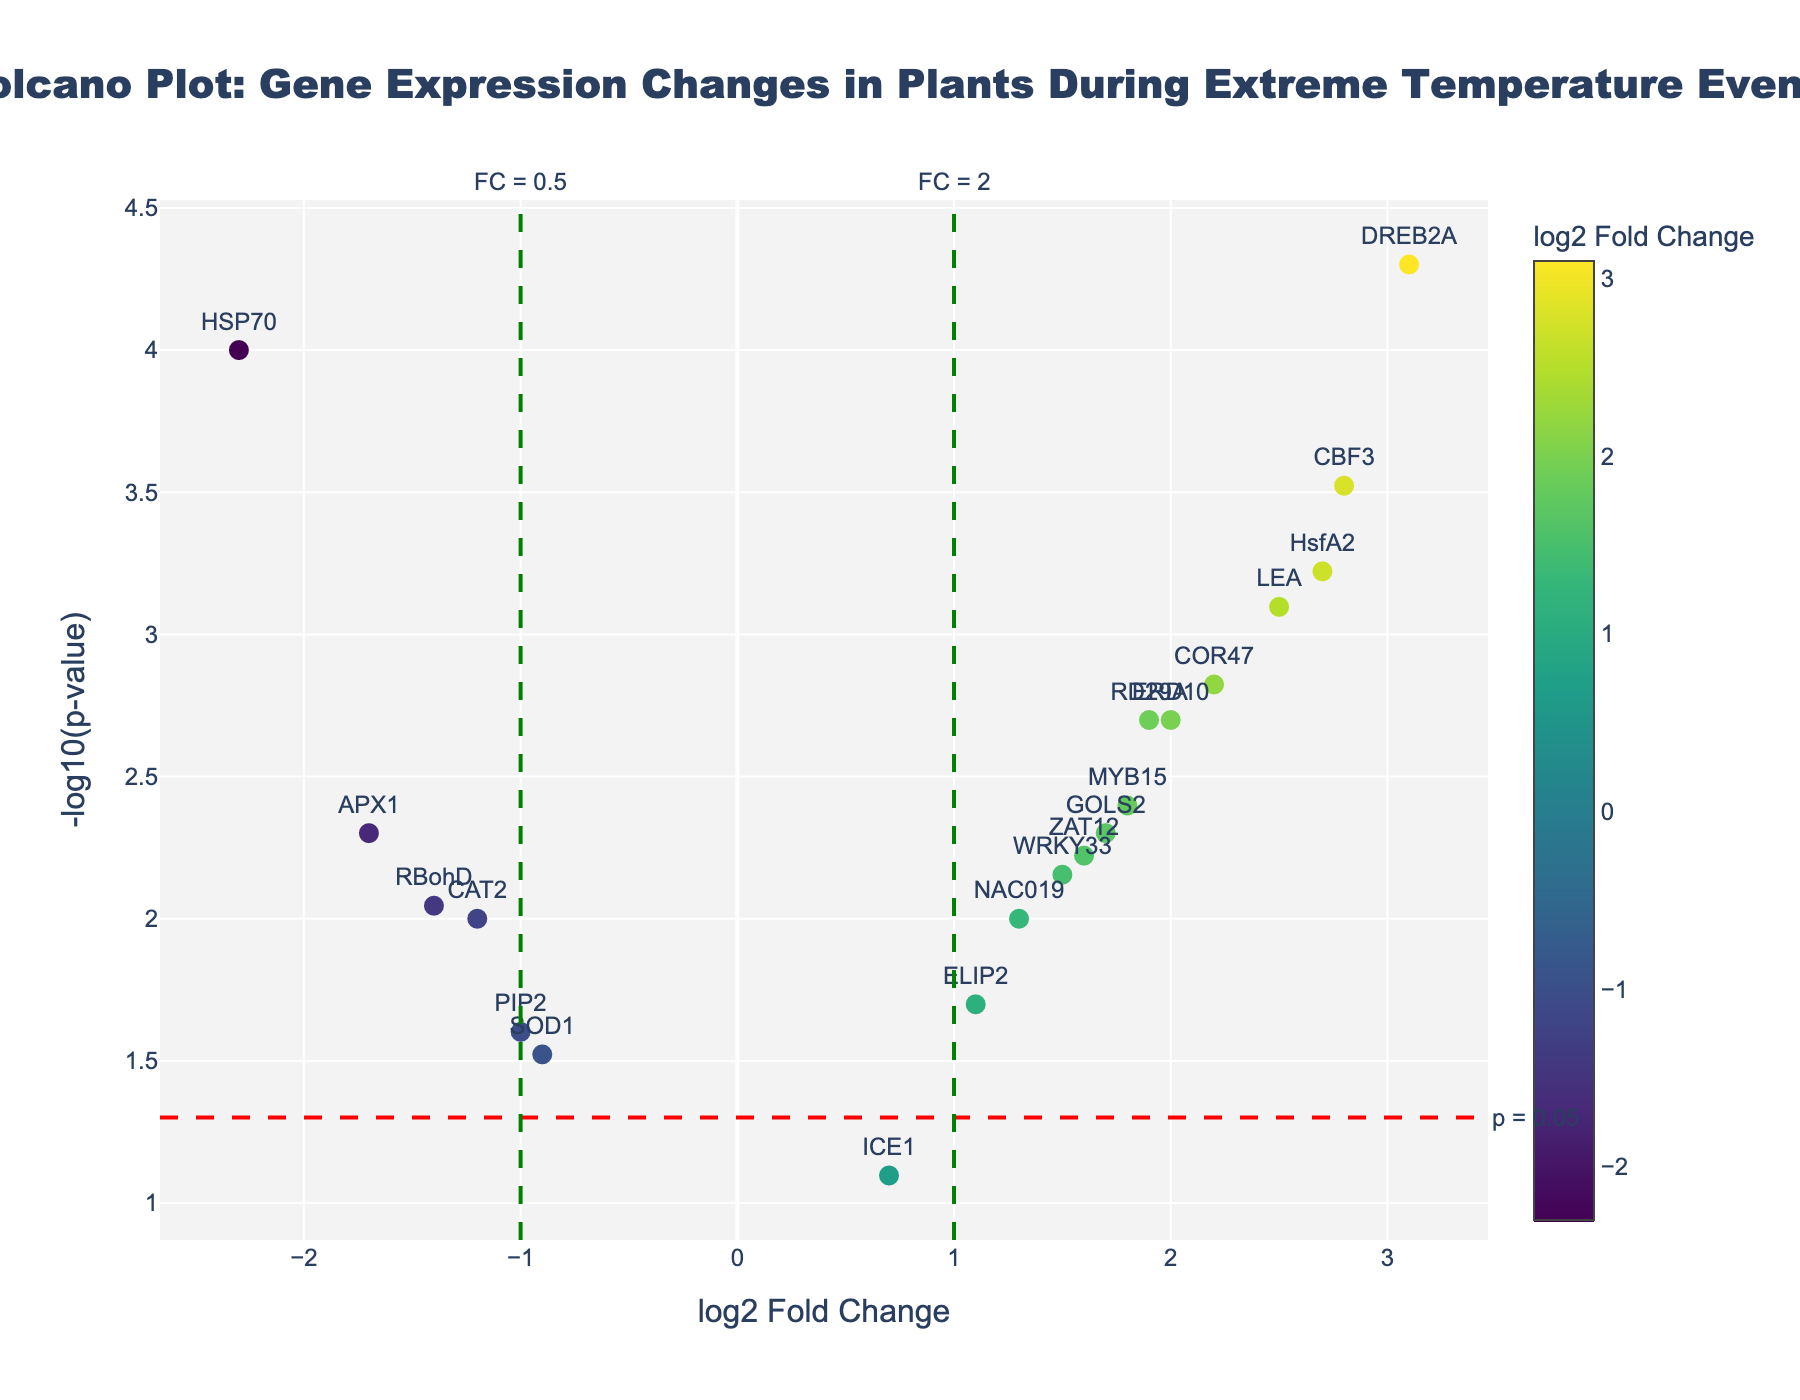What is the title of the plot? The title can be found at the top of the figure, providing an overview of what the plot represents. In this case, it reads "Volcano Plot: Gene Expression Changes in Plants During Extreme Temperature Events".
Answer: Volcano Plot: Gene Expression Changes in Plants During Extreme Temperature Events How many genes have a log2 fold change greater than 1? To determine this, we count the genes that have a log2 fold change (x-axis) value greater than 1. From the provided data, the genes with log2 fold change greater than 1 are DREB2A, CBF3, RD29A, LEA, WRKY33, MYB15, COR47, HsfA2, ERD10, GOLS2, ELIP2, and ZAT12, totaling 12.
Answer: 12 Which gene has the highest log2 fold change? We identify the point with the highest value along the x-axis (log2 fold change). From the data, DREB2A has the highest log2 fold change of 3.1.
Answer: DREB2A What is the significance threshold line value for p-value? The red horizontal dashed line represents the significance threshold on the y-axis (-log10(p-value)). The value is annotated as "p = 0.05", corresponding to -log10(0.05) ≈ 1.301.
Answer: 1.301 How many genes are below the p-value significance threshold? We need to count the genes that have a -log10(p-value) (y-axis) value less than 1.301. These genes are ICE1, CAT2, SOD1, ELIP2, NAC019, and PIP2, totaling 6.
Answer: 6 Which gene has the most significant p-value? The most significant p-value corresponds to the highest -log10(p-value) on the y-axis. According to the data, DREB2A has the most significant p-value with -log10(0.00005) ≈ 4.301.
Answer: DREB2A Which genes have a negative log2 fold change and a p-value less than 0.05? We look for genes with a log2 fold change (x-axis) less than 0 and a -log10(p-value) (y-axis) greater than 1.301. These genes are HSP70, APX1, RBohD, and CAT2.
Answer: HSP70, APX1, RBohD, CAT2 What is the color scale representing in the plot? The color of the markers represents the log2 fold change. The scale ranges from dark blue for the lowest values to light yellow for the highest values, as indicated by the color bar on the right side of the plot.
Answer: log2 fold change How many genes have both a log2 fold change greater than 2 and a p-value less than 0.001? We filter for genes with a log2 fold change (x-axis) greater than 2 and a -log10(p-value) (y-axis) greater than 3 (since -log10(0.001) = 3). These genes are DREB2A, CBF3, and HsfA2.
Answer: 3 